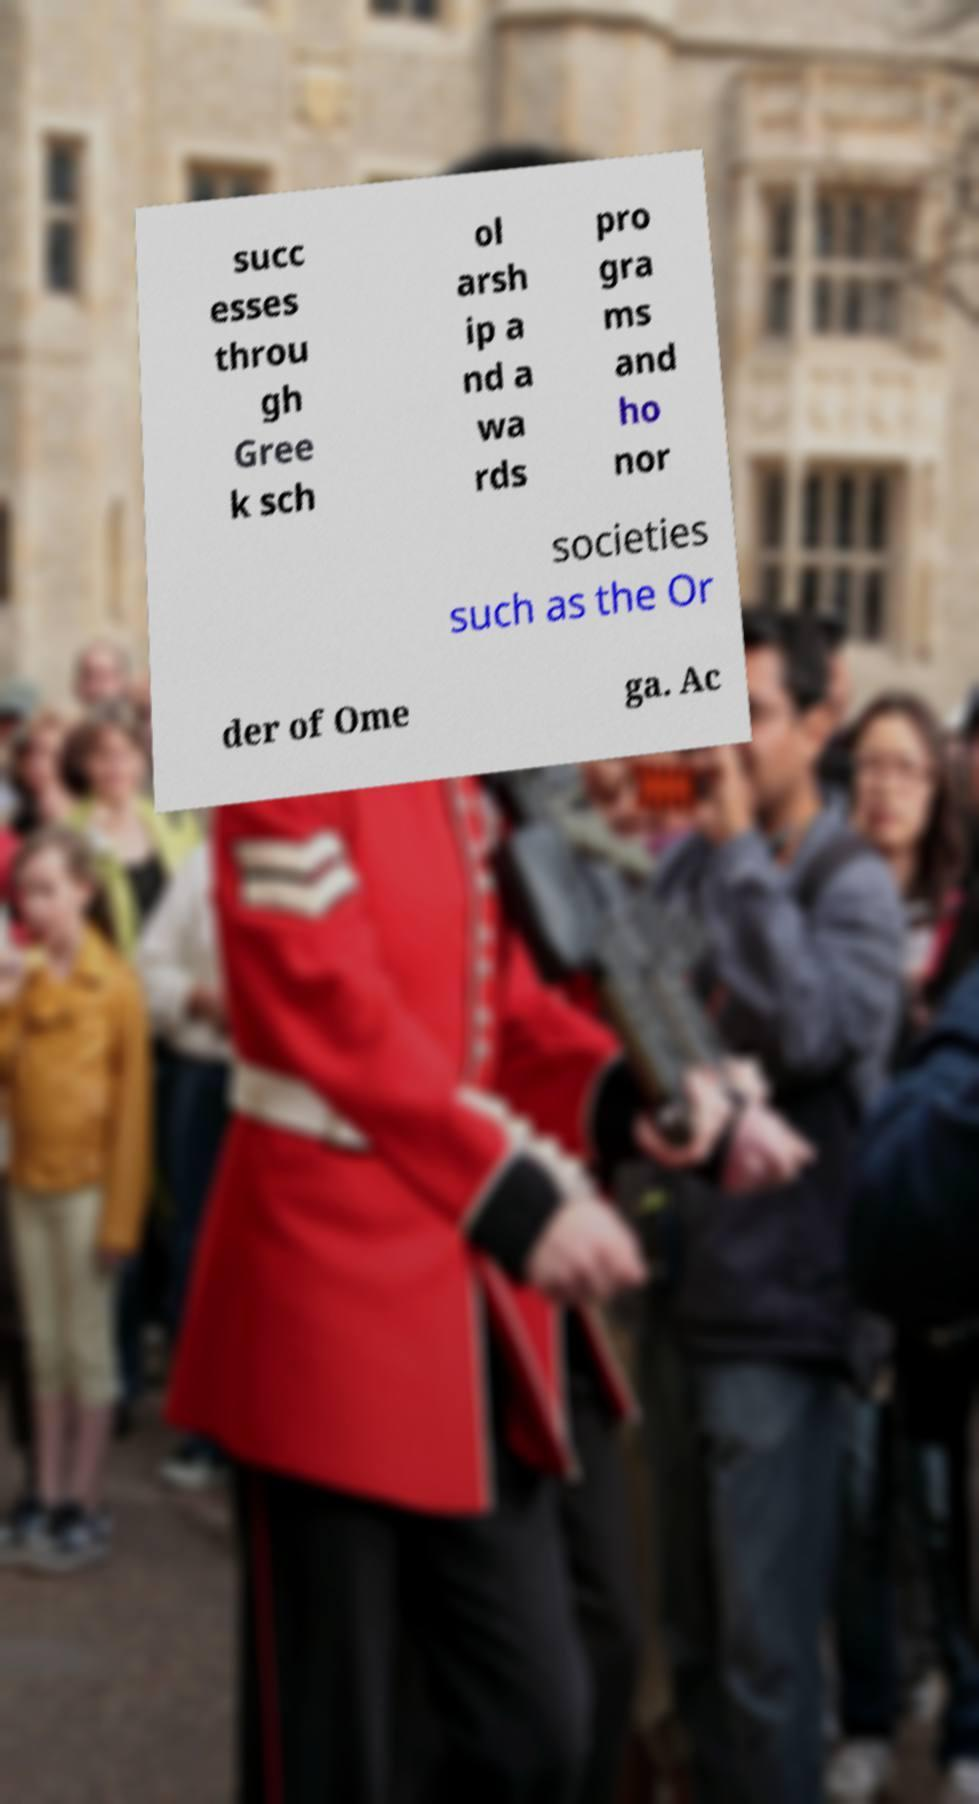Could you extract and type out the text from this image? succ esses throu gh Gree k sch ol arsh ip a nd a wa rds pro gra ms and ho nor societies such as the Or der of Ome ga. Ac 